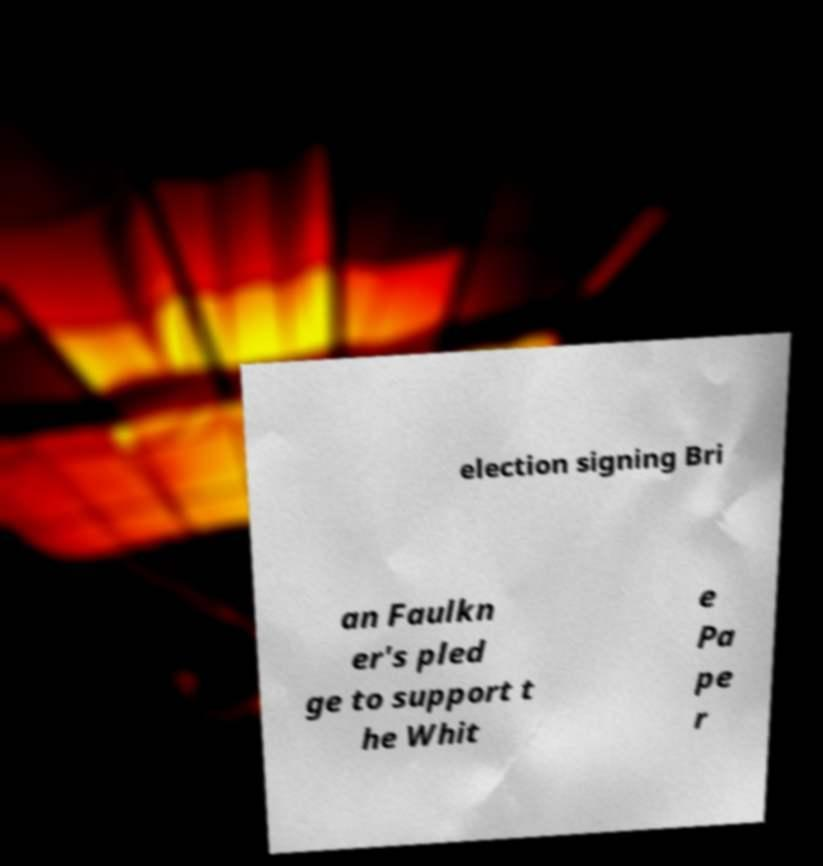Please read and relay the text visible in this image. What does it say? election signing Bri an Faulkn er's pled ge to support t he Whit e Pa pe r 